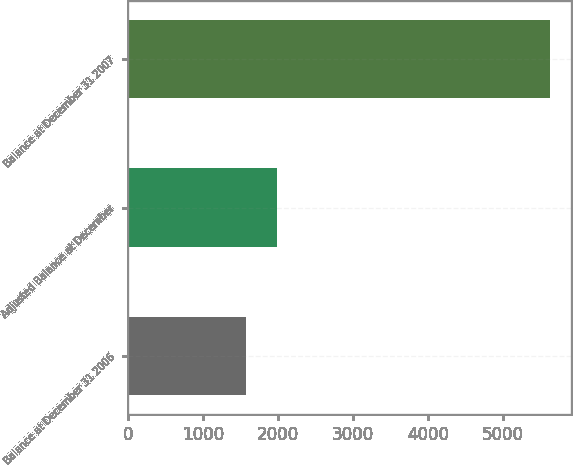Convert chart. <chart><loc_0><loc_0><loc_500><loc_500><bar_chart><fcel>Balance at December 31 2006<fcel>Adjusted Balance at December<fcel>Balance at December 31 2007<nl><fcel>1577<fcel>1982.3<fcel>5630<nl></chart> 